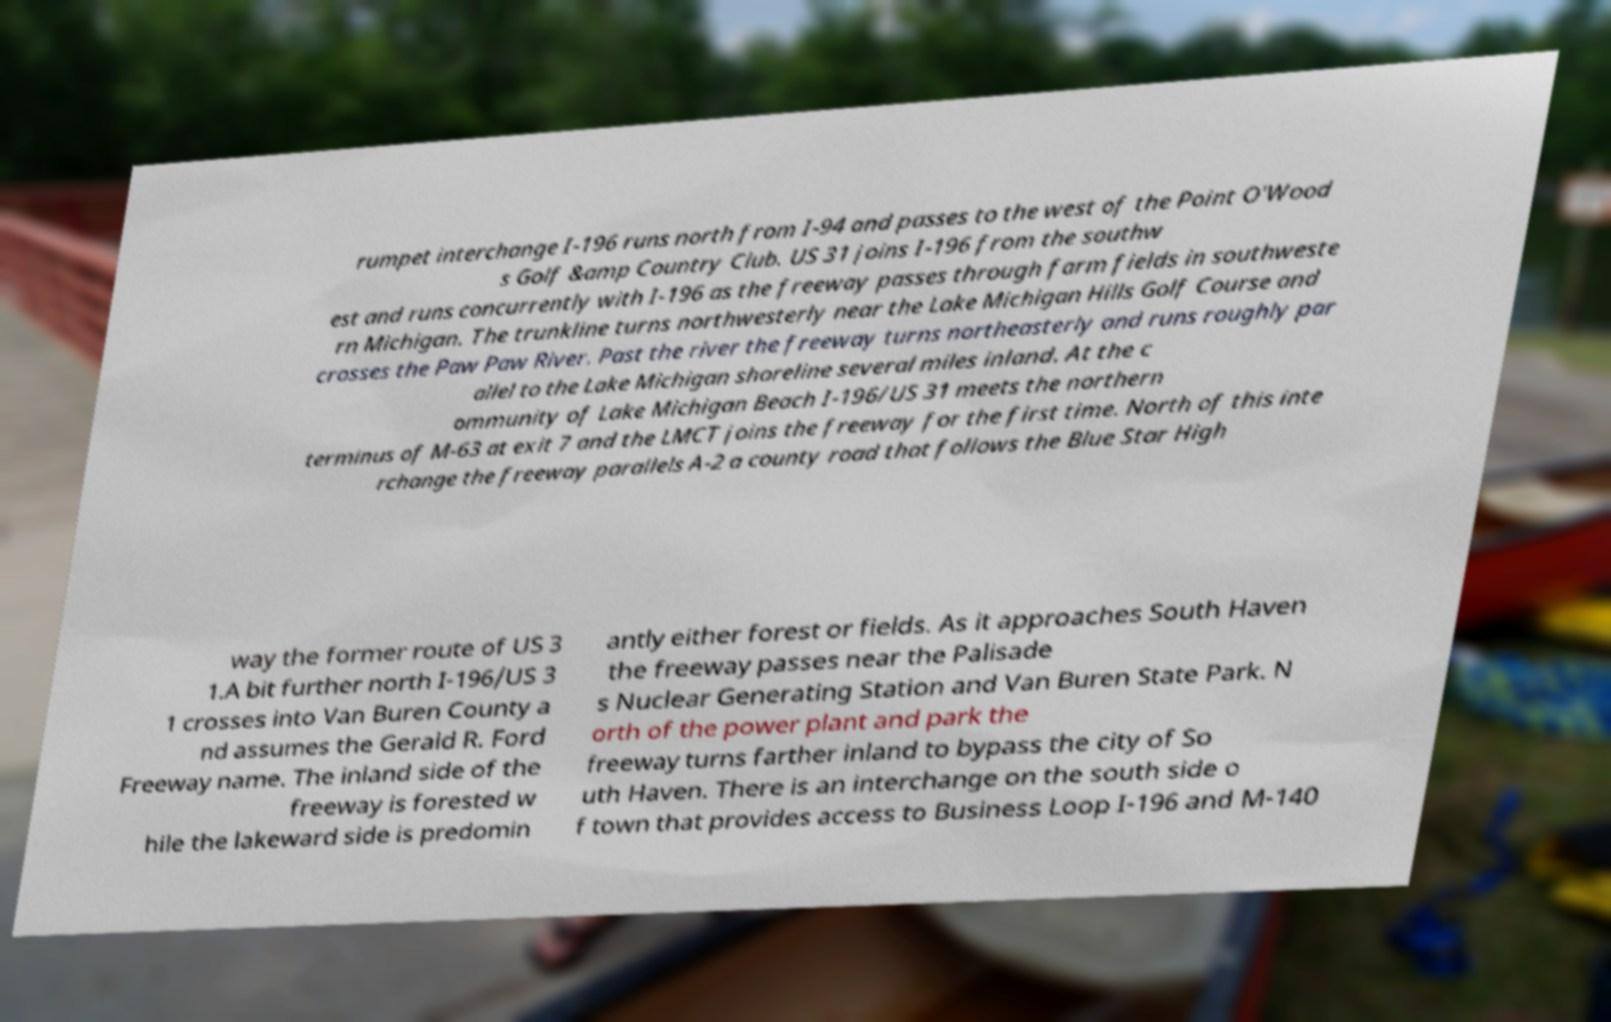I need the written content from this picture converted into text. Can you do that? rumpet interchange I-196 runs north from I-94 and passes to the west of the Point O'Wood s Golf &amp Country Club. US 31 joins I-196 from the southw est and runs concurrently with I-196 as the freeway passes through farm fields in southweste rn Michigan. The trunkline turns northwesterly near the Lake Michigan Hills Golf Course and crosses the Paw Paw River. Past the river the freeway turns northeasterly and runs roughly par allel to the Lake Michigan shoreline several miles inland. At the c ommunity of Lake Michigan Beach I-196/US 31 meets the northern terminus of M-63 at exit 7 and the LMCT joins the freeway for the first time. North of this inte rchange the freeway parallels A-2 a county road that follows the Blue Star High way the former route of US 3 1.A bit further north I-196/US 3 1 crosses into Van Buren County a nd assumes the Gerald R. Ford Freeway name. The inland side of the freeway is forested w hile the lakeward side is predomin antly either forest or fields. As it approaches South Haven the freeway passes near the Palisade s Nuclear Generating Station and Van Buren State Park. N orth of the power plant and park the freeway turns farther inland to bypass the city of So uth Haven. There is an interchange on the south side o f town that provides access to Business Loop I-196 and M-140 